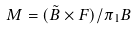<formula> <loc_0><loc_0><loc_500><loc_500>M = ( \tilde { B } \times F ) / \pi _ { 1 } B</formula> 